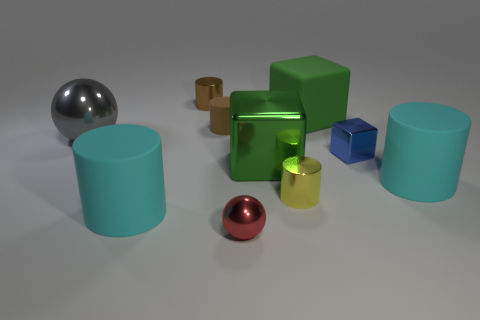What number of blue cubes are in front of the shiny object to the left of the cyan cylinder that is to the left of the tiny blue object?
Offer a terse response. 1. Are there fewer cubes that are in front of the yellow cylinder than green rubber blocks?
Ensure brevity in your answer.  Yes. Are there any other things that have the same shape as the small red metal object?
Your answer should be very brief. Yes. What is the shape of the tiny object to the left of the small matte cylinder?
Your answer should be very brief. Cylinder. There is a cyan thing left of the big green thing in front of the small brown matte cylinder right of the big gray metal sphere; what is its shape?
Offer a very short reply. Cylinder. What number of things are either large things or small balls?
Your response must be concise. 6. There is a big cyan rubber thing on the left side of the tiny brown matte cylinder; is it the same shape as the cyan rubber thing on the right side of the green metallic block?
Ensure brevity in your answer.  Yes. What number of things are both in front of the blue metal cube and on the left side of the brown metal thing?
Your answer should be very brief. 1. How many other things are there of the same size as the yellow cylinder?
Offer a terse response. 4. The cylinder that is both in front of the gray metallic thing and left of the yellow metallic cylinder is made of what material?
Make the answer very short. Rubber. 